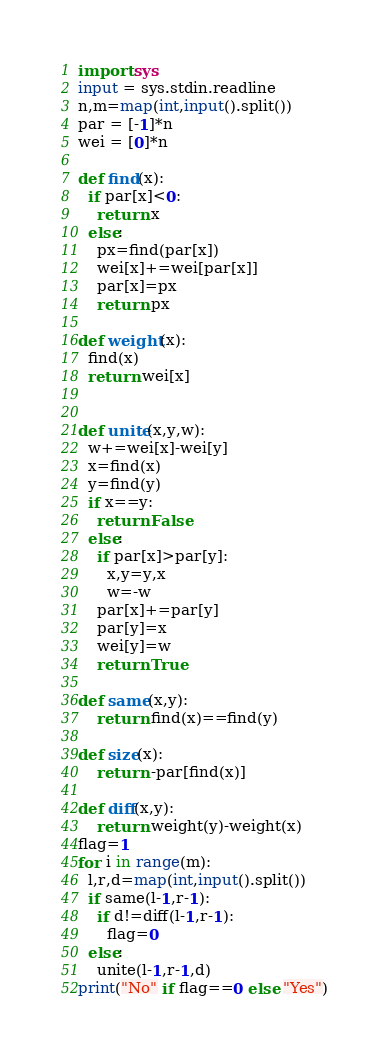Convert code to text. <code><loc_0><loc_0><loc_500><loc_500><_Python_>import sys
input = sys.stdin.readline
n,m=map(int,input().split())
par = [-1]*n
wei = [0]*n

def find(x):
  if par[x]<0:
    return x
  else:
    px=find(par[x])
    wei[x]+=wei[par[x]]
    par[x]=px
    return px

def weight(x):
  find(x)
  return wei[x]


def unite(x,y,w):
  w+=wei[x]-wei[y]
  x=find(x)
  y=find(y)    
  if x==y:
    return False
  else:
    if par[x]>par[y]:
      x,y=y,x
      w=-w
    par[x]+=par[y]
    par[y]=x
    wei[y]=w
    return True

def same(x,y):
    return find(x)==find(y)

def size(x):
    return -par[find(x)]

def diff(x,y):
    return weight(y)-weight(x)
flag=1
for i in range(m):
  l,r,d=map(int,input().split())
  if same(l-1,r-1):
    if d!=diff(l-1,r-1):
      flag=0
  else:
    unite(l-1,r-1,d)
print("No" if flag==0 else "Yes")</code> 